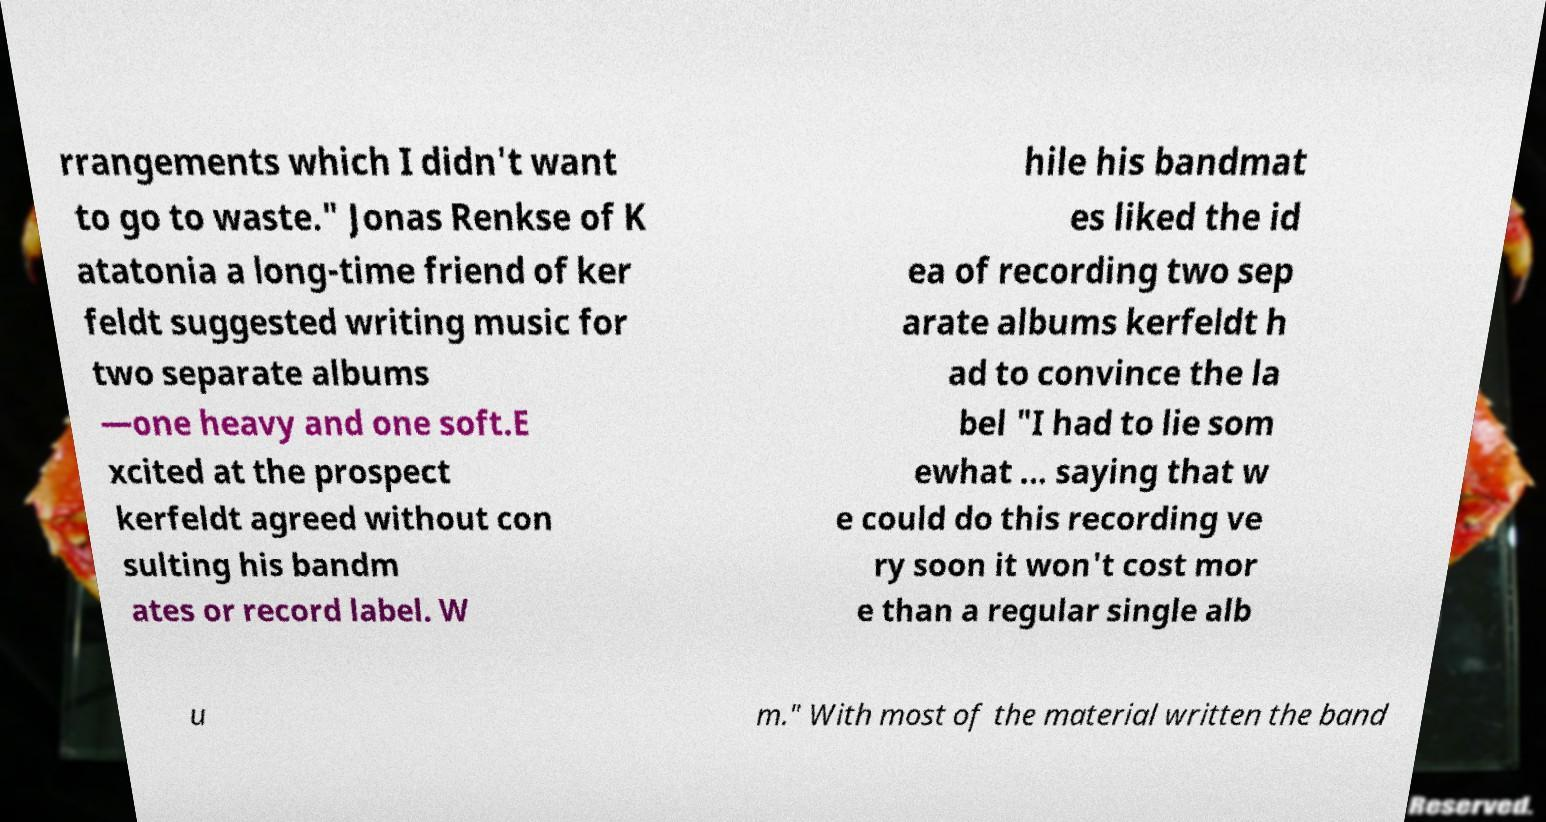There's text embedded in this image that I need extracted. Can you transcribe it verbatim? rrangements which I didn't want to go to waste." Jonas Renkse of K atatonia a long-time friend of ker feldt suggested writing music for two separate albums —one heavy and one soft.E xcited at the prospect kerfeldt agreed without con sulting his bandm ates or record label. W hile his bandmat es liked the id ea of recording two sep arate albums kerfeldt h ad to convince the la bel "I had to lie som ewhat ... saying that w e could do this recording ve ry soon it won't cost mor e than a regular single alb u m." With most of the material written the band 